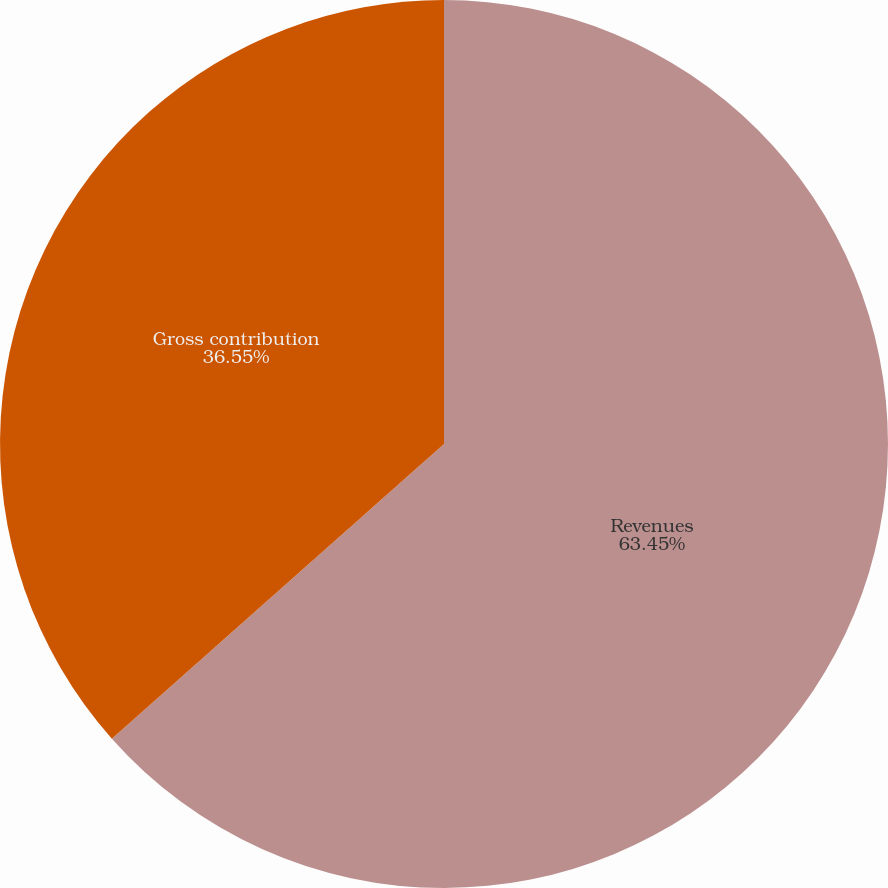Convert chart. <chart><loc_0><loc_0><loc_500><loc_500><pie_chart><fcel>Revenues<fcel>Gross contribution<nl><fcel>63.45%<fcel>36.55%<nl></chart> 